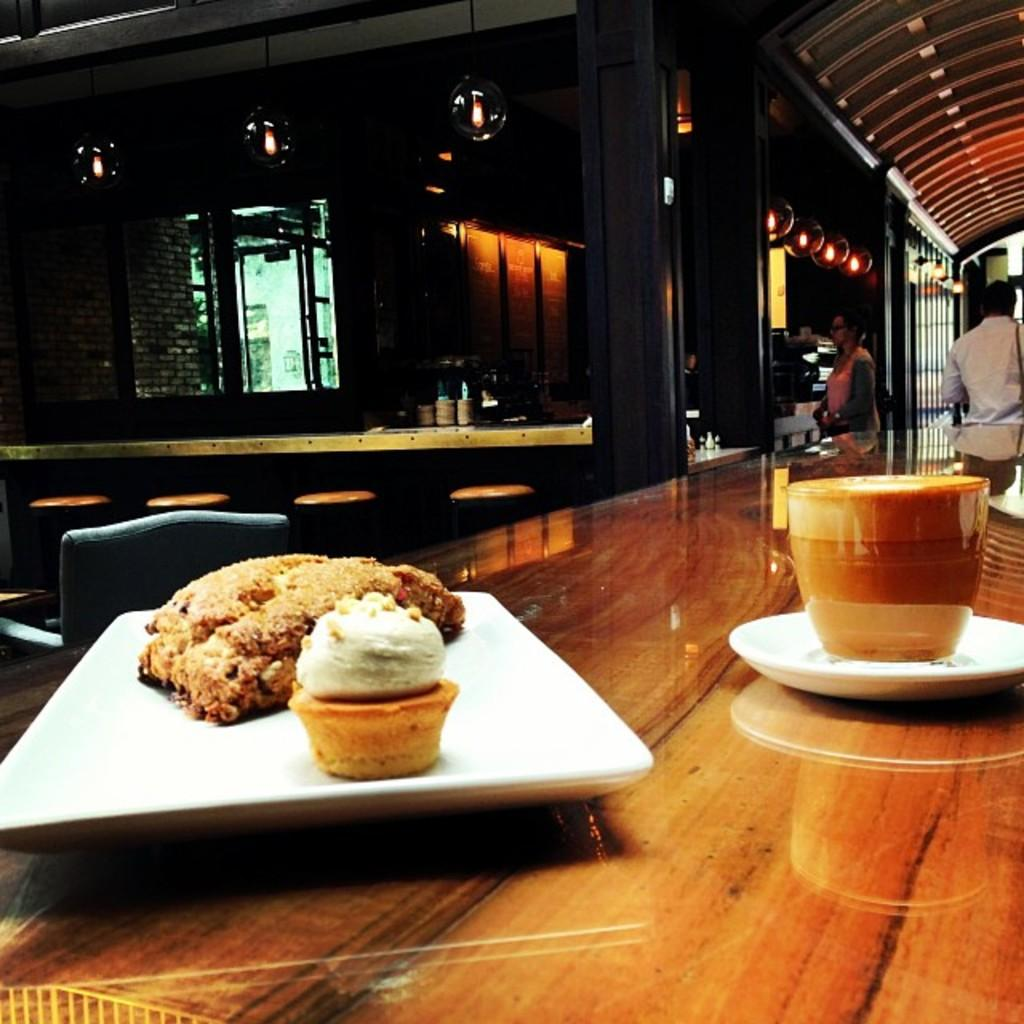What is on the plate that is visible in the image? There are food items on a plate in the image. What is on the table in the image? There is a cup on a table in the image. What can be seen in the background of the image? There is a pillar, a wall, and a window in the background of the image. How many snails are crawling on the food items in the image? There are no snails present in the image. Is this a birthday celebration, as indicated by the presence of a cake in the image? There is no cake or any indication of a birthday celebration in the image. 